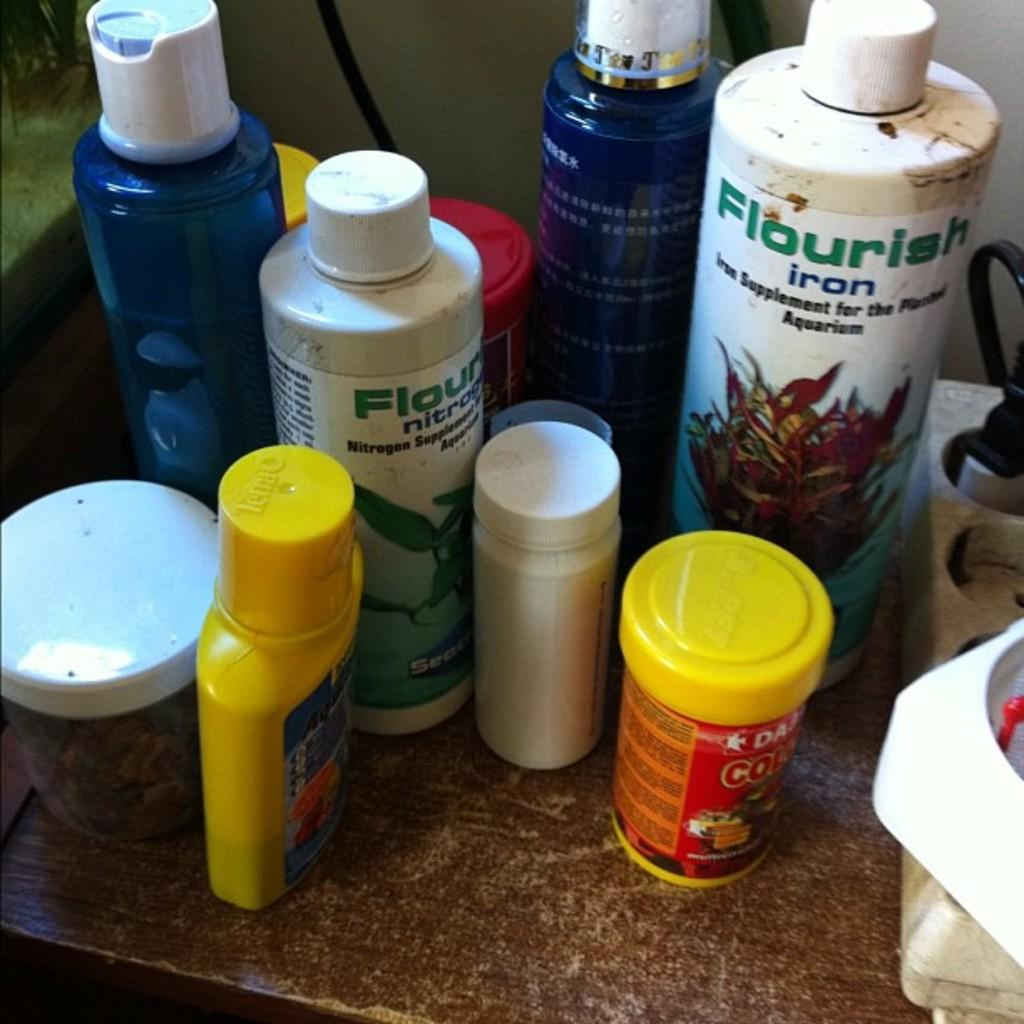What objects can be seen in the image? There are bottles and items on a wooden table in the image. Can you describe the background of the image? There is a wall in the background of the image, and there is also a wire visible. What health benefits can be gained from the theory mentioned in the image? There is no theory mentioned in the image, and therefore no health benefits can be discussed. 